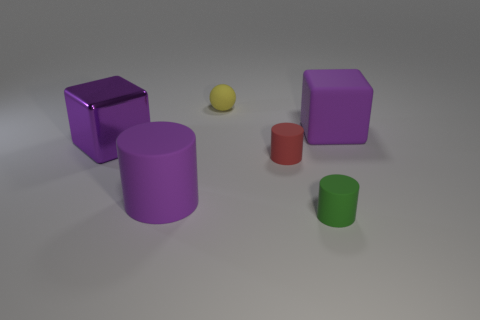Add 2 big purple metallic things. How many objects exist? 8 Subtract all cubes. How many objects are left? 4 Add 4 tiny green things. How many tiny green things exist? 5 Subtract 1 purple cubes. How many objects are left? 5 Subtract all big gray matte cubes. Subtract all tiny objects. How many objects are left? 3 Add 4 red rubber objects. How many red rubber objects are left? 5 